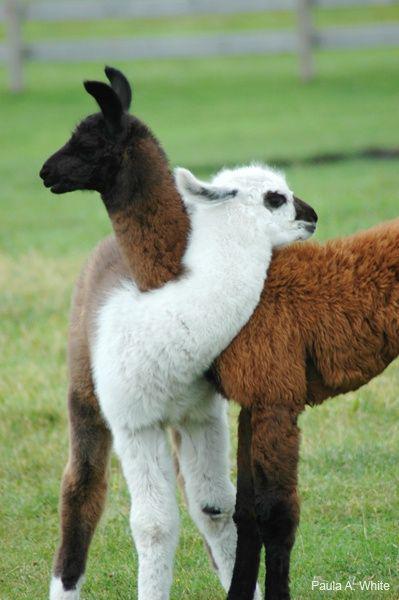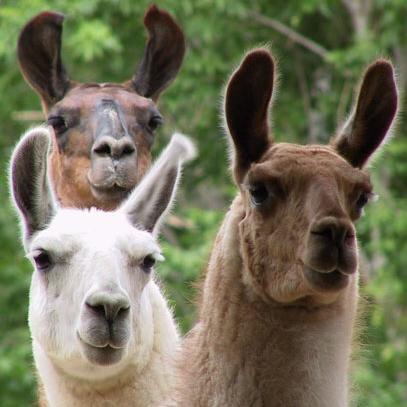The first image is the image on the left, the second image is the image on the right. Considering the images on both sides, is "There are at most 4 llamas in the pair of images." valid? Answer yes or no. No. The first image is the image on the left, the second image is the image on the right. Analyze the images presented: Is the assertion "The right image contains exactly three llamas with heads close together, one of them white, and the left image shows two heads close together, at least one belonging to a light-colored llama." valid? Answer yes or no. Yes. 